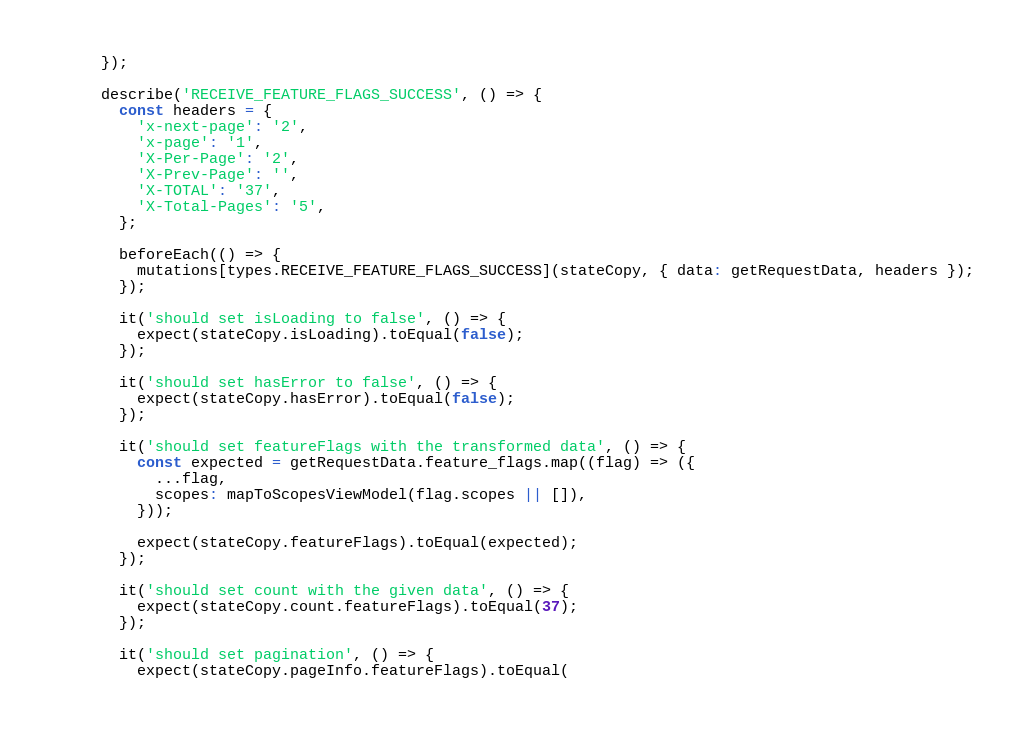Convert code to text. <code><loc_0><loc_0><loc_500><loc_500><_JavaScript_>  });

  describe('RECEIVE_FEATURE_FLAGS_SUCCESS', () => {
    const headers = {
      'x-next-page': '2',
      'x-page': '1',
      'X-Per-Page': '2',
      'X-Prev-Page': '',
      'X-TOTAL': '37',
      'X-Total-Pages': '5',
    };

    beforeEach(() => {
      mutations[types.RECEIVE_FEATURE_FLAGS_SUCCESS](stateCopy, { data: getRequestData, headers });
    });

    it('should set isLoading to false', () => {
      expect(stateCopy.isLoading).toEqual(false);
    });

    it('should set hasError to false', () => {
      expect(stateCopy.hasError).toEqual(false);
    });

    it('should set featureFlags with the transformed data', () => {
      const expected = getRequestData.feature_flags.map((flag) => ({
        ...flag,
        scopes: mapToScopesViewModel(flag.scopes || []),
      }));

      expect(stateCopy.featureFlags).toEqual(expected);
    });

    it('should set count with the given data', () => {
      expect(stateCopy.count.featureFlags).toEqual(37);
    });

    it('should set pagination', () => {
      expect(stateCopy.pageInfo.featureFlags).toEqual(</code> 